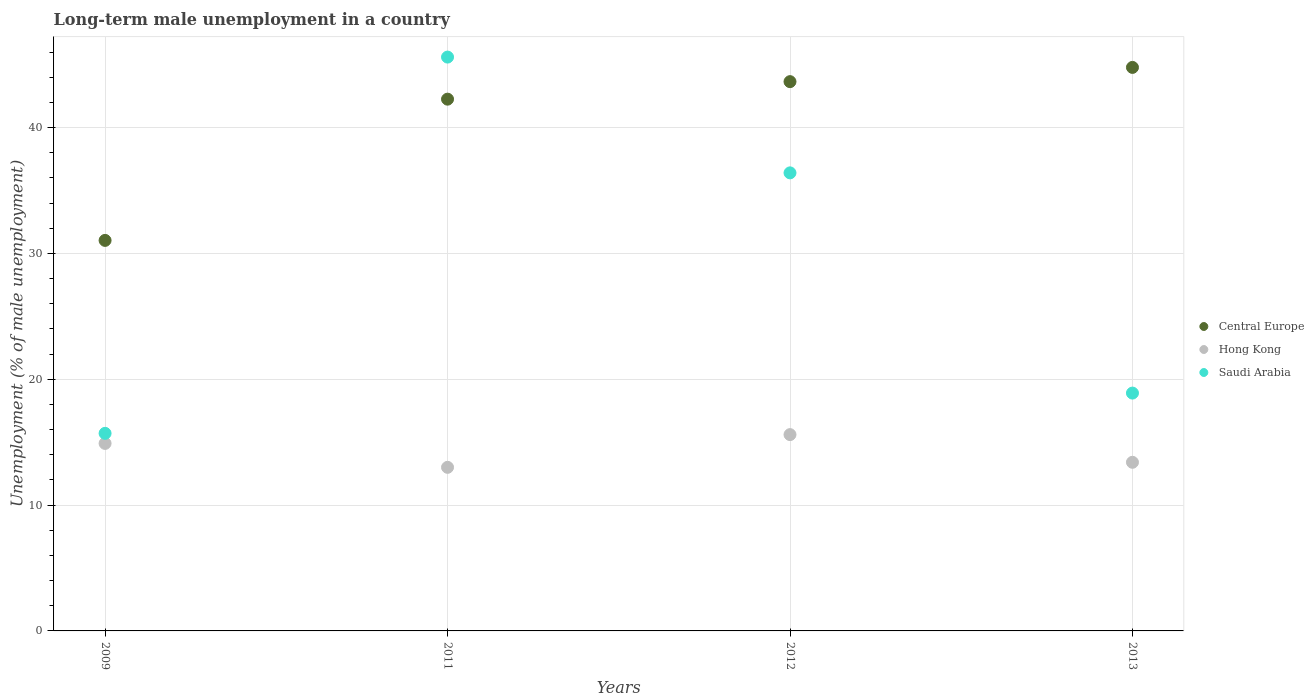Is the number of dotlines equal to the number of legend labels?
Keep it short and to the point. Yes. What is the percentage of long-term unemployed male population in Saudi Arabia in 2013?
Provide a succinct answer. 18.9. Across all years, what is the maximum percentage of long-term unemployed male population in Saudi Arabia?
Offer a very short reply. 45.6. Across all years, what is the minimum percentage of long-term unemployed male population in Central Europe?
Offer a terse response. 31.03. In which year was the percentage of long-term unemployed male population in Saudi Arabia maximum?
Give a very brief answer. 2011. In which year was the percentage of long-term unemployed male population in Central Europe minimum?
Keep it short and to the point. 2009. What is the total percentage of long-term unemployed male population in Hong Kong in the graph?
Offer a very short reply. 56.9. What is the difference between the percentage of long-term unemployed male population in Hong Kong in 2012 and that in 2013?
Keep it short and to the point. 2.2. What is the difference between the percentage of long-term unemployed male population in Hong Kong in 2012 and the percentage of long-term unemployed male population in Saudi Arabia in 2009?
Your answer should be compact. -0.1. What is the average percentage of long-term unemployed male population in Saudi Arabia per year?
Make the answer very short. 29.15. In the year 2013, what is the difference between the percentage of long-term unemployed male population in Central Europe and percentage of long-term unemployed male population in Saudi Arabia?
Give a very brief answer. 25.88. What is the ratio of the percentage of long-term unemployed male population in Saudi Arabia in 2009 to that in 2013?
Offer a very short reply. 0.83. What is the difference between the highest and the second highest percentage of long-term unemployed male population in Saudi Arabia?
Ensure brevity in your answer.  9.2. What is the difference between the highest and the lowest percentage of long-term unemployed male population in Hong Kong?
Make the answer very short. 2.6. In how many years, is the percentage of long-term unemployed male population in Hong Kong greater than the average percentage of long-term unemployed male population in Hong Kong taken over all years?
Your response must be concise. 2. Is the sum of the percentage of long-term unemployed male population in Saudi Arabia in 2009 and 2013 greater than the maximum percentage of long-term unemployed male population in Hong Kong across all years?
Provide a succinct answer. Yes. Is it the case that in every year, the sum of the percentage of long-term unemployed male population in Hong Kong and percentage of long-term unemployed male population in Central Europe  is greater than the percentage of long-term unemployed male population in Saudi Arabia?
Ensure brevity in your answer.  Yes. Does the percentage of long-term unemployed male population in Central Europe monotonically increase over the years?
Your response must be concise. Yes. Is the percentage of long-term unemployed male population in Hong Kong strictly less than the percentage of long-term unemployed male population in Saudi Arabia over the years?
Your answer should be very brief. Yes. Are the values on the major ticks of Y-axis written in scientific E-notation?
Provide a short and direct response. No. Does the graph contain grids?
Your response must be concise. Yes. Where does the legend appear in the graph?
Make the answer very short. Center right. What is the title of the graph?
Your answer should be compact. Long-term male unemployment in a country. Does "Iran" appear as one of the legend labels in the graph?
Ensure brevity in your answer.  No. What is the label or title of the X-axis?
Offer a terse response. Years. What is the label or title of the Y-axis?
Offer a terse response. Unemployment (% of male unemployment). What is the Unemployment (% of male unemployment) in Central Europe in 2009?
Ensure brevity in your answer.  31.03. What is the Unemployment (% of male unemployment) of Hong Kong in 2009?
Keep it short and to the point. 14.9. What is the Unemployment (% of male unemployment) in Saudi Arabia in 2009?
Keep it short and to the point. 15.7. What is the Unemployment (% of male unemployment) of Central Europe in 2011?
Give a very brief answer. 42.26. What is the Unemployment (% of male unemployment) in Saudi Arabia in 2011?
Offer a very short reply. 45.6. What is the Unemployment (% of male unemployment) in Central Europe in 2012?
Offer a terse response. 43.65. What is the Unemployment (% of male unemployment) in Hong Kong in 2012?
Give a very brief answer. 15.6. What is the Unemployment (% of male unemployment) of Saudi Arabia in 2012?
Offer a very short reply. 36.4. What is the Unemployment (% of male unemployment) of Central Europe in 2013?
Your answer should be compact. 44.78. What is the Unemployment (% of male unemployment) in Hong Kong in 2013?
Make the answer very short. 13.4. What is the Unemployment (% of male unemployment) of Saudi Arabia in 2013?
Your answer should be compact. 18.9. Across all years, what is the maximum Unemployment (% of male unemployment) in Central Europe?
Provide a short and direct response. 44.78. Across all years, what is the maximum Unemployment (% of male unemployment) of Hong Kong?
Ensure brevity in your answer.  15.6. Across all years, what is the maximum Unemployment (% of male unemployment) of Saudi Arabia?
Provide a short and direct response. 45.6. Across all years, what is the minimum Unemployment (% of male unemployment) in Central Europe?
Offer a terse response. 31.03. Across all years, what is the minimum Unemployment (% of male unemployment) of Hong Kong?
Give a very brief answer. 13. Across all years, what is the minimum Unemployment (% of male unemployment) in Saudi Arabia?
Make the answer very short. 15.7. What is the total Unemployment (% of male unemployment) in Central Europe in the graph?
Your answer should be compact. 161.72. What is the total Unemployment (% of male unemployment) of Hong Kong in the graph?
Give a very brief answer. 56.9. What is the total Unemployment (% of male unemployment) of Saudi Arabia in the graph?
Provide a short and direct response. 116.6. What is the difference between the Unemployment (% of male unemployment) in Central Europe in 2009 and that in 2011?
Offer a terse response. -11.22. What is the difference between the Unemployment (% of male unemployment) in Saudi Arabia in 2009 and that in 2011?
Provide a short and direct response. -29.9. What is the difference between the Unemployment (% of male unemployment) of Central Europe in 2009 and that in 2012?
Offer a very short reply. -12.62. What is the difference between the Unemployment (% of male unemployment) of Saudi Arabia in 2009 and that in 2012?
Ensure brevity in your answer.  -20.7. What is the difference between the Unemployment (% of male unemployment) in Central Europe in 2009 and that in 2013?
Ensure brevity in your answer.  -13.75. What is the difference between the Unemployment (% of male unemployment) of Hong Kong in 2009 and that in 2013?
Keep it short and to the point. 1.5. What is the difference between the Unemployment (% of male unemployment) in Central Europe in 2011 and that in 2012?
Offer a terse response. -1.39. What is the difference between the Unemployment (% of male unemployment) in Saudi Arabia in 2011 and that in 2012?
Your response must be concise. 9.2. What is the difference between the Unemployment (% of male unemployment) of Central Europe in 2011 and that in 2013?
Offer a terse response. -2.52. What is the difference between the Unemployment (% of male unemployment) of Saudi Arabia in 2011 and that in 2013?
Ensure brevity in your answer.  26.7. What is the difference between the Unemployment (% of male unemployment) in Central Europe in 2012 and that in 2013?
Provide a short and direct response. -1.13. What is the difference between the Unemployment (% of male unemployment) in Hong Kong in 2012 and that in 2013?
Provide a short and direct response. 2.2. What is the difference between the Unemployment (% of male unemployment) in Central Europe in 2009 and the Unemployment (% of male unemployment) in Hong Kong in 2011?
Provide a short and direct response. 18.03. What is the difference between the Unemployment (% of male unemployment) in Central Europe in 2009 and the Unemployment (% of male unemployment) in Saudi Arabia in 2011?
Provide a short and direct response. -14.57. What is the difference between the Unemployment (% of male unemployment) of Hong Kong in 2009 and the Unemployment (% of male unemployment) of Saudi Arabia in 2011?
Offer a terse response. -30.7. What is the difference between the Unemployment (% of male unemployment) in Central Europe in 2009 and the Unemployment (% of male unemployment) in Hong Kong in 2012?
Provide a succinct answer. 15.43. What is the difference between the Unemployment (% of male unemployment) of Central Europe in 2009 and the Unemployment (% of male unemployment) of Saudi Arabia in 2012?
Keep it short and to the point. -5.37. What is the difference between the Unemployment (% of male unemployment) in Hong Kong in 2009 and the Unemployment (% of male unemployment) in Saudi Arabia in 2012?
Provide a succinct answer. -21.5. What is the difference between the Unemployment (% of male unemployment) of Central Europe in 2009 and the Unemployment (% of male unemployment) of Hong Kong in 2013?
Provide a short and direct response. 17.63. What is the difference between the Unemployment (% of male unemployment) in Central Europe in 2009 and the Unemployment (% of male unemployment) in Saudi Arabia in 2013?
Make the answer very short. 12.13. What is the difference between the Unemployment (% of male unemployment) in Central Europe in 2011 and the Unemployment (% of male unemployment) in Hong Kong in 2012?
Ensure brevity in your answer.  26.66. What is the difference between the Unemployment (% of male unemployment) in Central Europe in 2011 and the Unemployment (% of male unemployment) in Saudi Arabia in 2012?
Provide a succinct answer. 5.86. What is the difference between the Unemployment (% of male unemployment) in Hong Kong in 2011 and the Unemployment (% of male unemployment) in Saudi Arabia in 2012?
Provide a succinct answer. -23.4. What is the difference between the Unemployment (% of male unemployment) of Central Europe in 2011 and the Unemployment (% of male unemployment) of Hong Kong in 2013?
Offer a terse response. 28.86. What is the difference between the Unemployment (% of male unemployment) in Central Europe in 2011 and the Unemployment (% of male unemployment) in Saudi Arabia in 2013?
Your answer should be compact. 23.36. What is the difference between the Unemployment (% of male unemployment) of Central Europe in 2012 and the Unemployment (% of male unemployment) of Hong Kong in 2013?
Your answer should be very brief. 30.25. What is the difference between the Unemployment (% of male unemployment) of Central Europe in 2012 and the Unemployment (% of male unemployment) of Saudi Arabia in 2013?
Keep it short and to the point. 24.75. What is the average Unemployment (% of male unemployment) in Central Europe per year?
Offer a terse response. 40.43. What is the average Unemployment (% of male unemployment) of Hong Kong per year?
Provide a short and direct response. 14.22. What is the average Unemployment (% of male unemployment) in Saudi Arabia per year?
Ensure brevity in your answer.  29.15. In the year 2009, what is the difference between the Unemployment (% of male unemployment) of Central Europe and Unemployment (% of male unemployment) of Hong Kong?
Keep it short and to the point. 16.13. In the year 2009, what is the difference between the Unemployment (% of male unemployment) of Central Europe and Unemployment (% of male unemployment) of Saudi Arabia?
Make the answer very short. 15.33. In the year 2011, what is the difference between the Unemployment (% of male unemployment) in Central Europe and Unemployment (% of male unemployment) in Hong Kong?
Your answer should be very brief. 29.26. In the year 2011, what is the difference between the Unemployment (% of male unemployment) in Central Europe and Unemployment (% of male unemployment) in Saudi Arabia?
Your answer should be very brief. -3.34. In the year 2011, what is the difference between the Unemployment (% of male unemployment) in Hong Kong and Unemployment (% of male unemployment) in Saudi Arabia?
Ensure brevity in your answer.  -32.6. In the year 2012, what is the difference between the Unemployment (% of male unemployment) of Central Europe and Unemployment (% of male unemployment) of Hong Kong?
Offer a very short reply. 28.05. In the year 2012, what is the difference between the Unemployment (% of male unemployment) of Central Europe and Unemployment (% of male unemployment) of Saudi Arabia?
Provide a short and direct response. 7.25. In the year 2012, what is the difference between the Unemployment (% of male unemployment) of Hong Kong and Unemployment (% of male unemployment) of Saudi Arabia?
Provide a short and direct response. -20.8. In the year 2013, what is the difference between the Unemployment (% of male unemployment) in Central Europe and Unemployment (% of male unemployment) in Hong Kong?
Offer a very short reply. 31.38. In the year 2013, what is the difference between the Unemployment (% of male unemployment) of Central Europe and Unemployment (% of male unemployment) of Saudi Arabia?
Your answer should be compact. 25.88. What is the ratio of the Unemployment (% of male unemployment) in Central Europe in 2009 to that in 2011?
Your response must be concise. 0.73. What is the ratio of the Unemployment (% of male unemployment) of Hong Kong in 2009 to that in 2011?
Your response must be concise. 1.15. What is the ratio of the Unemployment (% of male unemployment) in Saudi Arabia in 2009 to that in 2011?
Provide a succinct answer. 0.34. What is the ratio of the Unemployment (% of male unemployment) in Central Europe in 2009 to that in 2012?
Offer a terse response. 0.71. What is the ratio of the Unemployment (% of male unemployment) of Hong Kong in 2009 to that in 2012?
Provide a succinct answer. 0.96. What is the ratio of the Unemployment (% of male unemployment) of Saudi Arabia in 2009 to that in 2012?
Your answer should be compact. 0.43. What is the ratio of the Unemployment (% of male unemployment) of Central Europe in 2009 to that in 2013?
Offer a very short reply. 0.69. What is the ratio of the Unemployment (% of male unemployment) in Hong Kong in 2009 to that in 2013?
Provide a succinct answer. 1.11. What is the ratio of the Unemployment (% of male unemployment) of Saudi Arabia in 2009 to that in 2013?
Your answer should be very brief. 0.83. What is the ratio of the Unemployment (% of male unemployment) in Central Europe in 2011 to that in 2012?
Ensure brevity in your answer.  0.97. What is the ratio of the Unemployment (% of male unemployment) in Saudi Arabia in 2011 to that in 2012?
Give a very brief answer. 1.25. What is the ratio of the Unemployment (% of male unemployment) in Central Europe in 2011 to that in 2013?
Offer a very short reply. 0.94. What is the ratio of the Unemployment (% of male unemployment) of Hong Kong in 2011 to that in 2013?
Offer a very short reply. 0.97. What is the ratio of the Unemployment (% of male unemployment) of Saudi Arabia in 2011 to that in 2013?
Give a very brief answer. 2.41. What is the ratio of the Unemployment (% of male unemployment) in Central Europe in 2012 to that in 2013?
Your response must be concise. 0.97. What is the ratio of the Unemployment (% of male unemployment) of Hong Kong in 2012 to that in 2013?
Your response must be concise. 1.16. What is the ratio of the Unemployment (% of male unemployment) of Saudi Arabia in 2012 to that in 2013?
Offer a terse response. 1.93. What is the difference between the highest and the second highest Unemployment (% of male unemployment) in Central Europe?
Provide a succinct answer. 1.13. What is the difference between the highest and the lowest Unemployment (% of male unemployment) in Central Europe?
Provide a succinct answer. 13.75. What is the difference between the highest and the lowest Unemployment (% of male unemployment) of Hong Kong?
Make the answer very short. 2.6. What is the difference between the highest and the lowest Unemployment (% of male unemployment) in Saudi Arabia?
Offer a terse response. 29.9. 